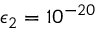<formula> <loc_0><loc_0><loc_500><loc_500>\epsilon _ { 2 } = 1 0 ^ { - 2 0 }</formula> 